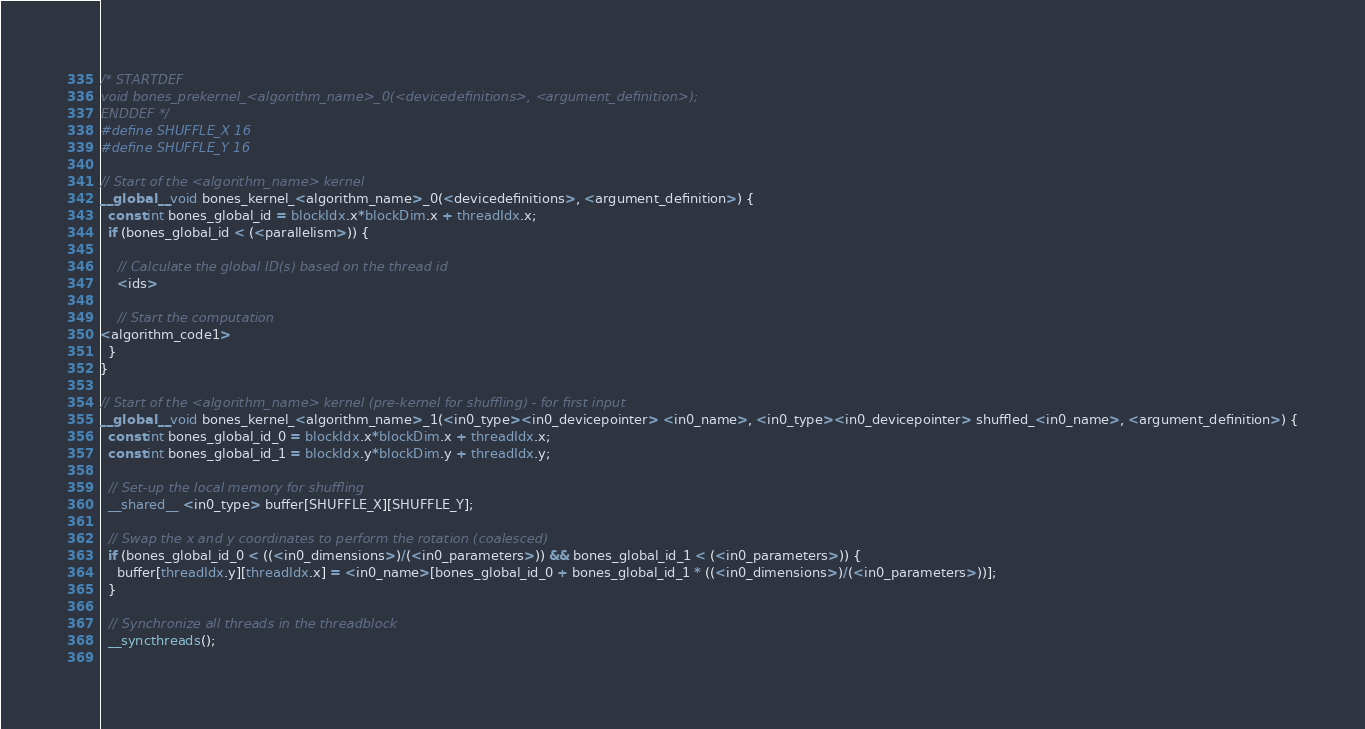Convert code to text. <code><loc_0><loc_0><loc_500><loc_500><_Cuda_>/* STARTDEF
void bones_prekernel_<algorithm_name>_0(<devicedefinitions>, <argument_definition>);
ENDDEF */
#define SHUFFLE_X 16
#define SHUFFLE_Y 16

// Start of the <algorithm_name> kernel
__global__ void bones_kernel_<algorithm_name>_0(<devicedefinitions>, <argument_definition>) {
  const int bones_global_id = blockIdx.x*blockDim.x + threadIdx.x;
  if (bones_global_id < (<parallelism>)) {
    
    // Calculate the global ID(s) based on the thread id
    <ids>
    
    // Start the computation
<algorithm_code1>
  }
}

// Start of the <algorithm_name> kernel (pre-kernel for shuffling) - for first input
__global__ void bones_kernel_<algorithm_name>_1(<in0_type><in0_devicepointer> <in0_name>, <in0_type><in0_devicepointer> shuffled_<in0_name>, <argument_definition>) {
  const int bones_global_id_0 = blockIdx.x*blockDim.x + threadIdx.x;
  const int bones_global_id_1 = blockIdx.y*blockDim.y + threadIdx.y;
  
  // Set-up the local memory for shuffling
  __shared__ <in0_type> buffer[SHUFFLE_X][SHUFFLE_Y];
  
  // Swap the x and y coordinates to perform the rotation (coalesced)
  if (bones_global_id_0 < ((<in0_dimensions>)/(<in0_parameters>)) && bones_global_id_1 < (<in0_parameters>)) {
    buffer[threadIdx.y][threadIdx.x] = <in0_name>[bones_global_id_0 + bones_global_id_1 * ((<in0_dimensions>)/(<in0_parameters>))];
  }
  
  // Synchronize all threads in the threadblock
  __syncthreads();
  </code> 